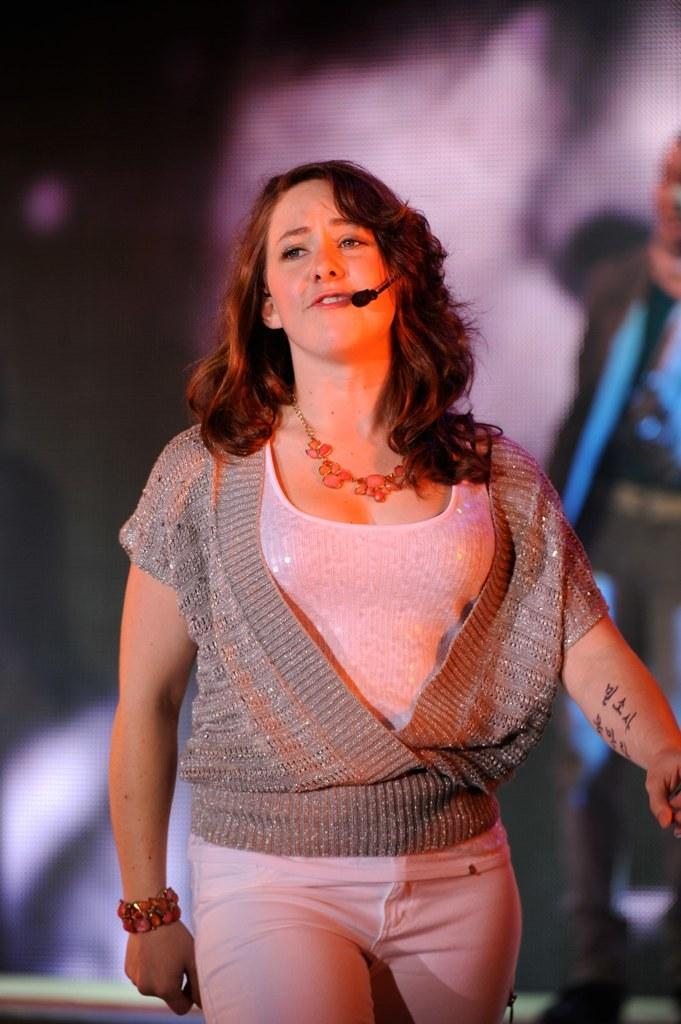What is the main subject in the foreground of the picture? There is a beautiful woman in the foreground of the picture. What is the woman doing in the image? The woman is singing. Can you describe the woman's possible movement in the image? The woman might be walking. How would you describe the background of the image? The background of the image is blurred. How many balls are visible in the image? There are no balls present in the image. What type of crow can be seen interacting with the woman in the image? There is no crow present in the image; the woman is singing alone. Can you tell me where the toothbrush is located in the image? There is no toothbrush present in the image. 